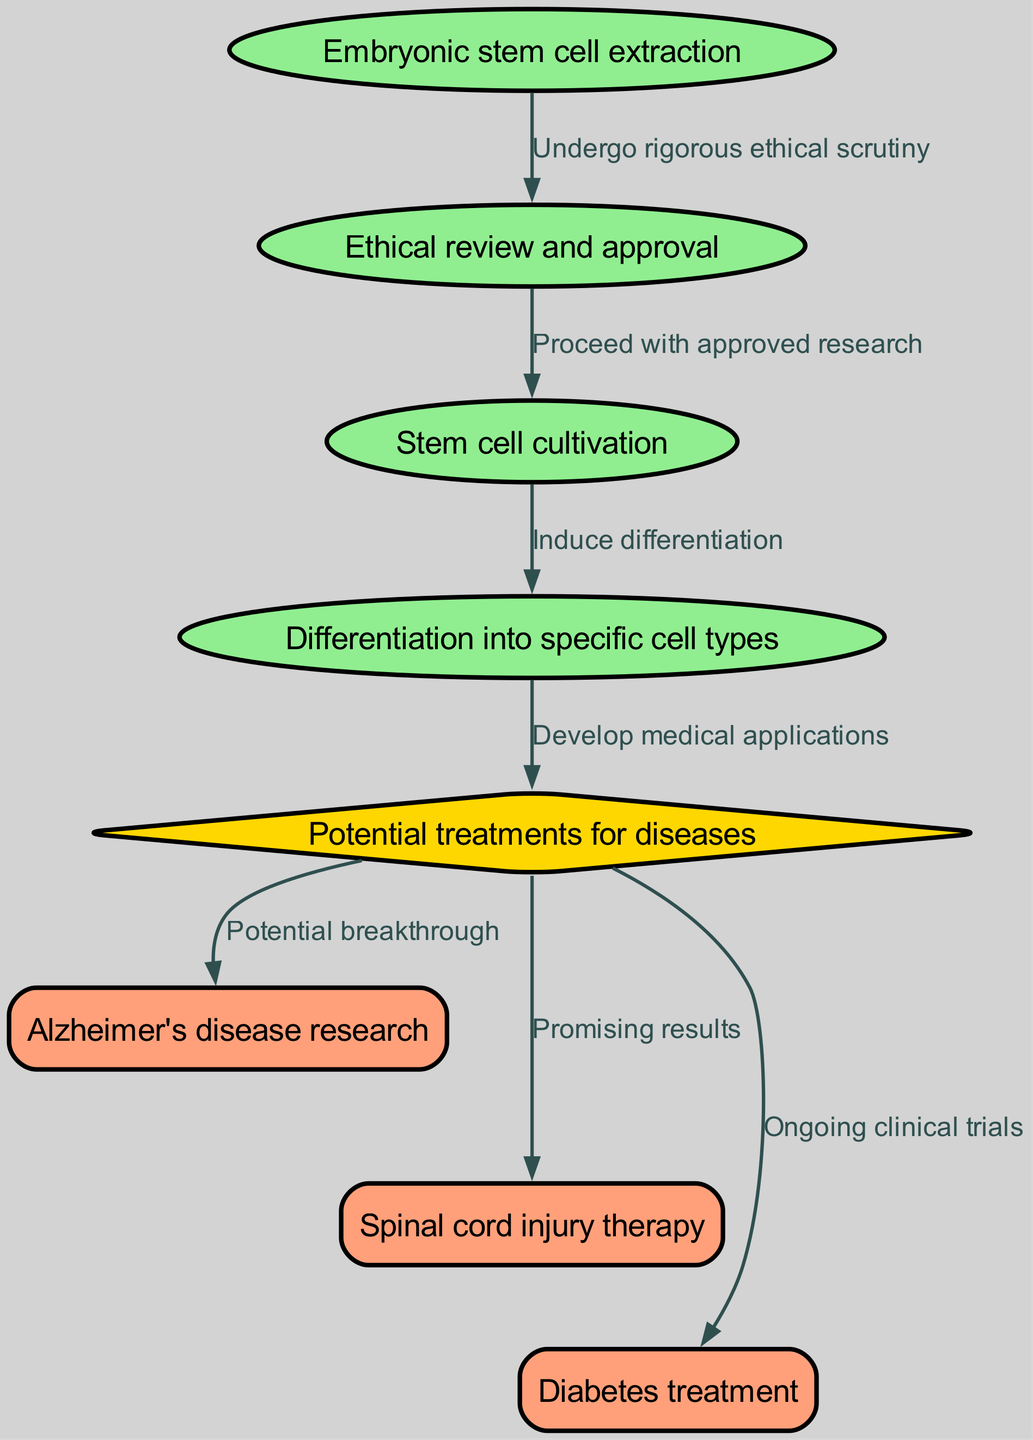What is the first step in the stem cell research process? The diagram shows that the first step is labeled as "Embryonic stem cell extraction," which is identified as the starting point of the flowchart.
Answer: Embryonic stem cell extraction How many different medical applications are mentioned in the diagram? The diagram lists three distinct medical applications: Alzheimer's disease research, spinal cord injury therapy, and diabetes treatment, which indicates there are three applications.
Answer: Three What type of cell culture follows the ethical review? After the "Ethical review and approval," the next node represents "Stem cell cultivation," indicating this is the type of cell culture that follows the review.
Answer: Stem cell cultivation What is the shape of the node that represents potential treatments for diseases? The node corresponding to "Potential treatments for diseases" is shaped as a diamond, which is a visual feature used in the diagram to denote decision points.
Answer: Diamond Which process leads to developing medical applications? The flow from "Differentiation into specific cell types" leads directly to the node "Potential treatments for diseases," showing that differentiation is the process that leads to developing medical applications.
Answer: Differentiation into specific cell types What does the edge leading from "Potential treatments for diseases" to "Alzheimer's disease research" indicate? The edge labeled "Potential breakthrough" suggests that the research in this area might yield significant advancements in treating Alzheimer's disease.
Answer: Potential breakthrough How many connections are there leading from "Potential treatments for diseases"? There are three edges leading out from the "Potential treatments for diseases" node, each connecting to different medical research applications: Alzheimer's disease research, spinal cord injury therapy, and diabetes treatment.
Answer: Three What step occurs after stem cell cultivation in the diagram? Following "Stem cell cultivation," the next procedure illustrated is "Differentiation into specific cell types," which is the next logical process in stem cell research.
Answer: Differentiation into specific cell types What ethical consideration is required before proceeding with stem cell research? The diagram specifies that "Ethical review and approval" must occur after embryonic stem cell extraction, indicating this ethical consideration is necessary before further research.
Answer: Ethical review and approval 